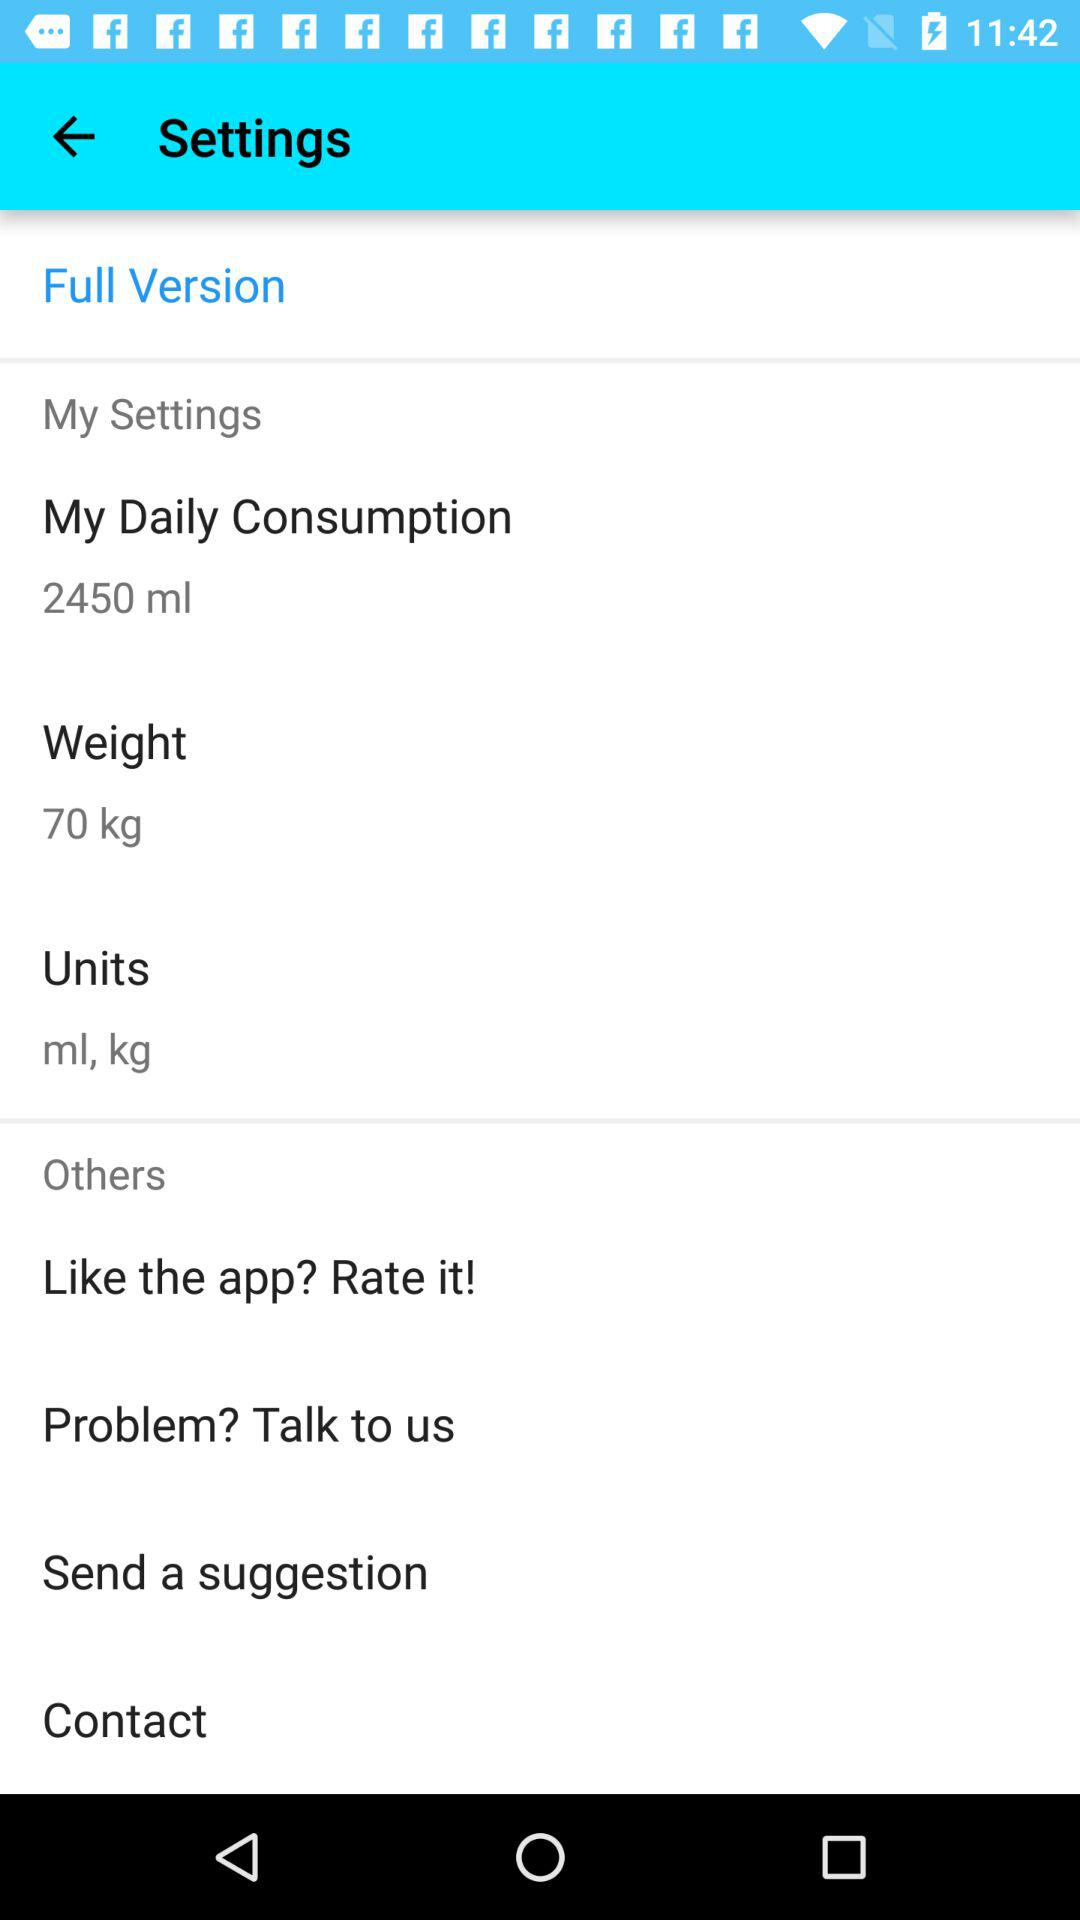What is the weight? The weight is 70 kg. 